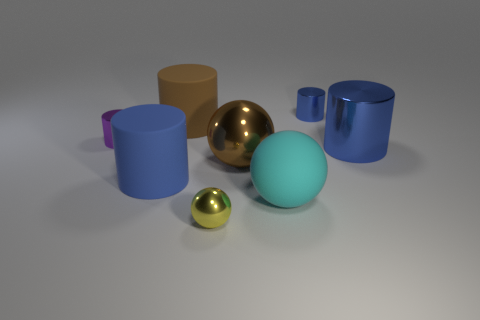What is the material of the brown cylinder that is the same size as the blue rubber cylinder?
Provide a succinct answer. Rubber. The thing to the right of the small cylinder to the right of the big cyan rubber sphere is made of what material?
Your response must be concise. Metal. Are there any big blue cylinders that have the same material as the purple cylinder?
Offer a very short reply. Yes. The brown thing to the right of the tiny object in front of the large blue object right of the blue rubber thing is what shape?
Your answer should be very brief. Sphere. What material is the small blue cylinder?
Provide a succinct answer. Metal. There is a small sphere that is made of the same material as the small purple thing; what color is it?
Give a very brief answer. Yellow. There is a large blue cylinder to the right of the big blue matte cylinder; are there any large brown matte cylinders that are behind it?
Provide a succinct answer. Yes. How many other objects are there of the same shape as the cyan object?
Provide a succinct answer. 2. Does the tiny shiny thing that is left of the blue matte cylinder have the same shape as the tiny shiny object in front of the purple metal object?
Make the answer very short. No. There is a blue metal cylinder in front of the tiny metallic cylinder left of the matte ball; what number of big blue matte cylinders are behind it?
Your answer should be very brief. 0. 